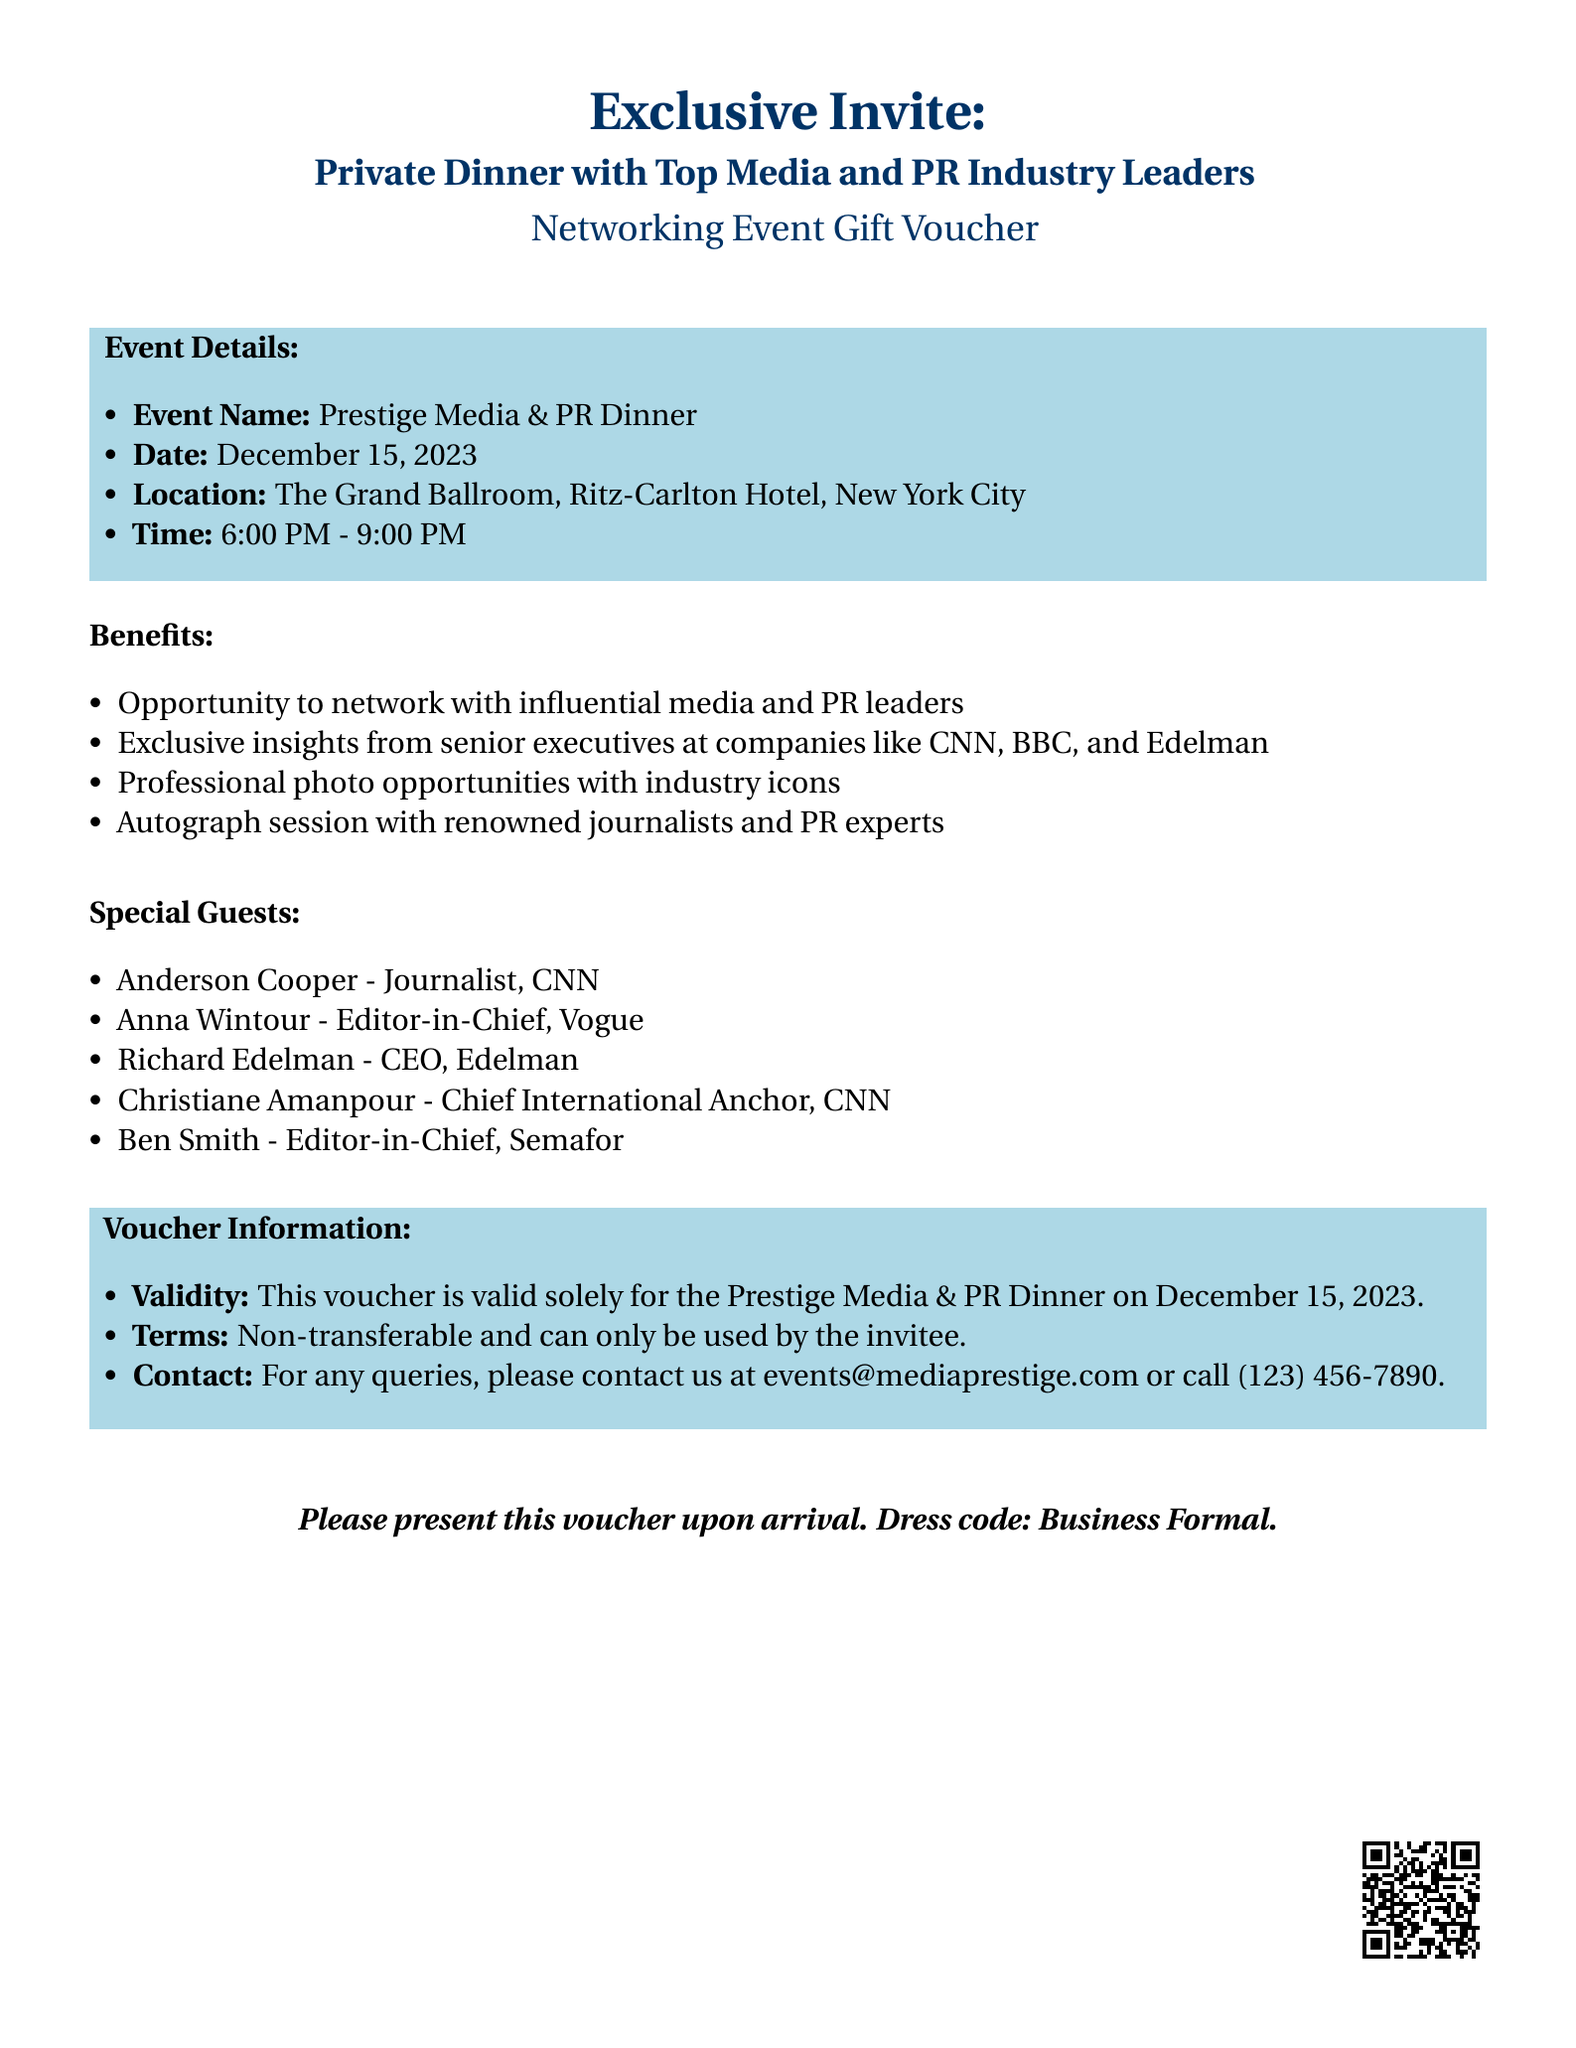What is the event name? The event name is listed at the beginning of the document under "Event Details."
Answer: Prestige Media & PR Dinner What is the date of the event? The date of the event is specified in the "Event Details" section.
Answer: December 15, 2023 Where is the event located? The location of the event is found in the "Event Details" section.
Answer: The Grand Ballroom, Ritz-Carlton Hotel, New York City What is the time of the event? The time of the event is provided in the "Event Details" section.
Answer: 6:00 PM - 9:00 PM Who is one of the special guests? Special guests are listed in a separate section, and the question asks for one name.
Answer: Anderson Cooper What is one benefit of attending this event? The benefits are mentioned in a list, and this asks for one specific example.
Answer: Opportunity to network with influential media and PR leaders How should attendees dress for the event? The dress code is mentioned at the bottom of the document.
Answer: Business Formal What is the contact email for inquiries? The contact information for queries is provided towards the end of the document.
Answer: events@mediaprestige.com Is the voucher transferable? The terms related to the voucher state its non-transferable nature.
Answer: Non-transferable 